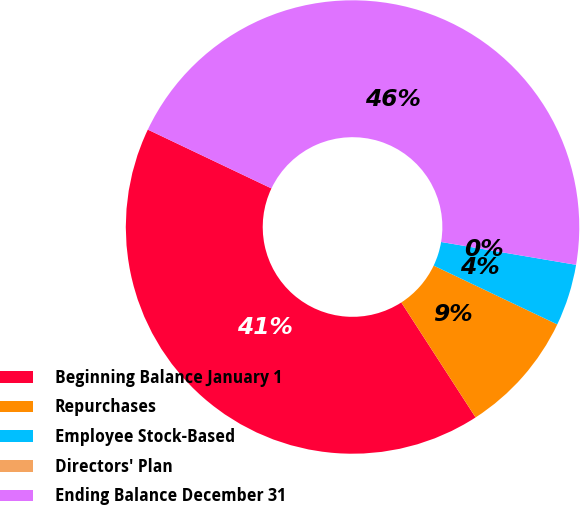Convert chart. <chart><loc_0><loc_0><loc_500><loc_500><pie_chart><fcel>Beginning Balance January 1<fcel>Repurchases<fcel>Employee Stock-Based<fcel>Directors' Plan<fcel>Ending Balance December 31<nl><fcel>41.19%<fcel>8.8%<fcel>4.4%<fcel>0.0%<fcel>45.59%<nl></chart> 